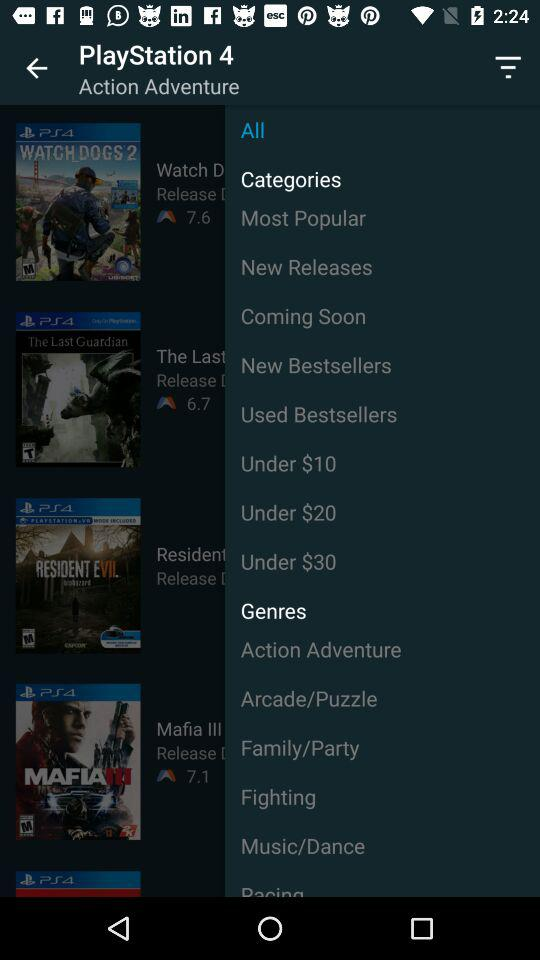What is the rating of "WATCH DOGS 2" on "PlayStation 4"? The rating of "WATCH DOGS 2" on "PlayStation 4" is 7.6. 